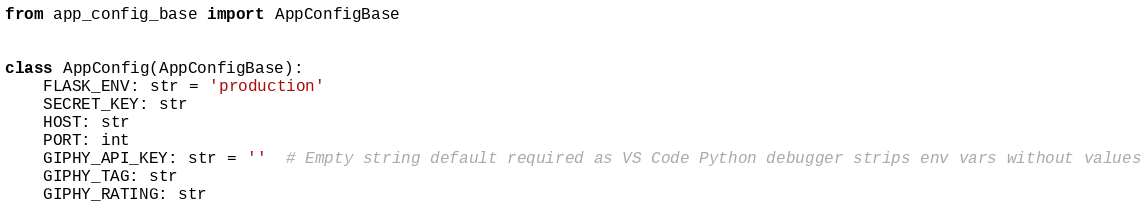<code> <loc_0><loc_0><loc_500><loc_500><_Python_>from app_config_base import AppConfigBase


class AppConfig(AppConfigBase):
    FLASK_ENV: str = 'production'
    SECRET_KEY: str
    HOST: str
    PORT: int
    GIPHY_API_KEY: str = ''  # Empty string default required as VS Code Python debugger strips env vars without values
    GIPHY_TAG: str
    GIPHY_RATING: str
</code> 